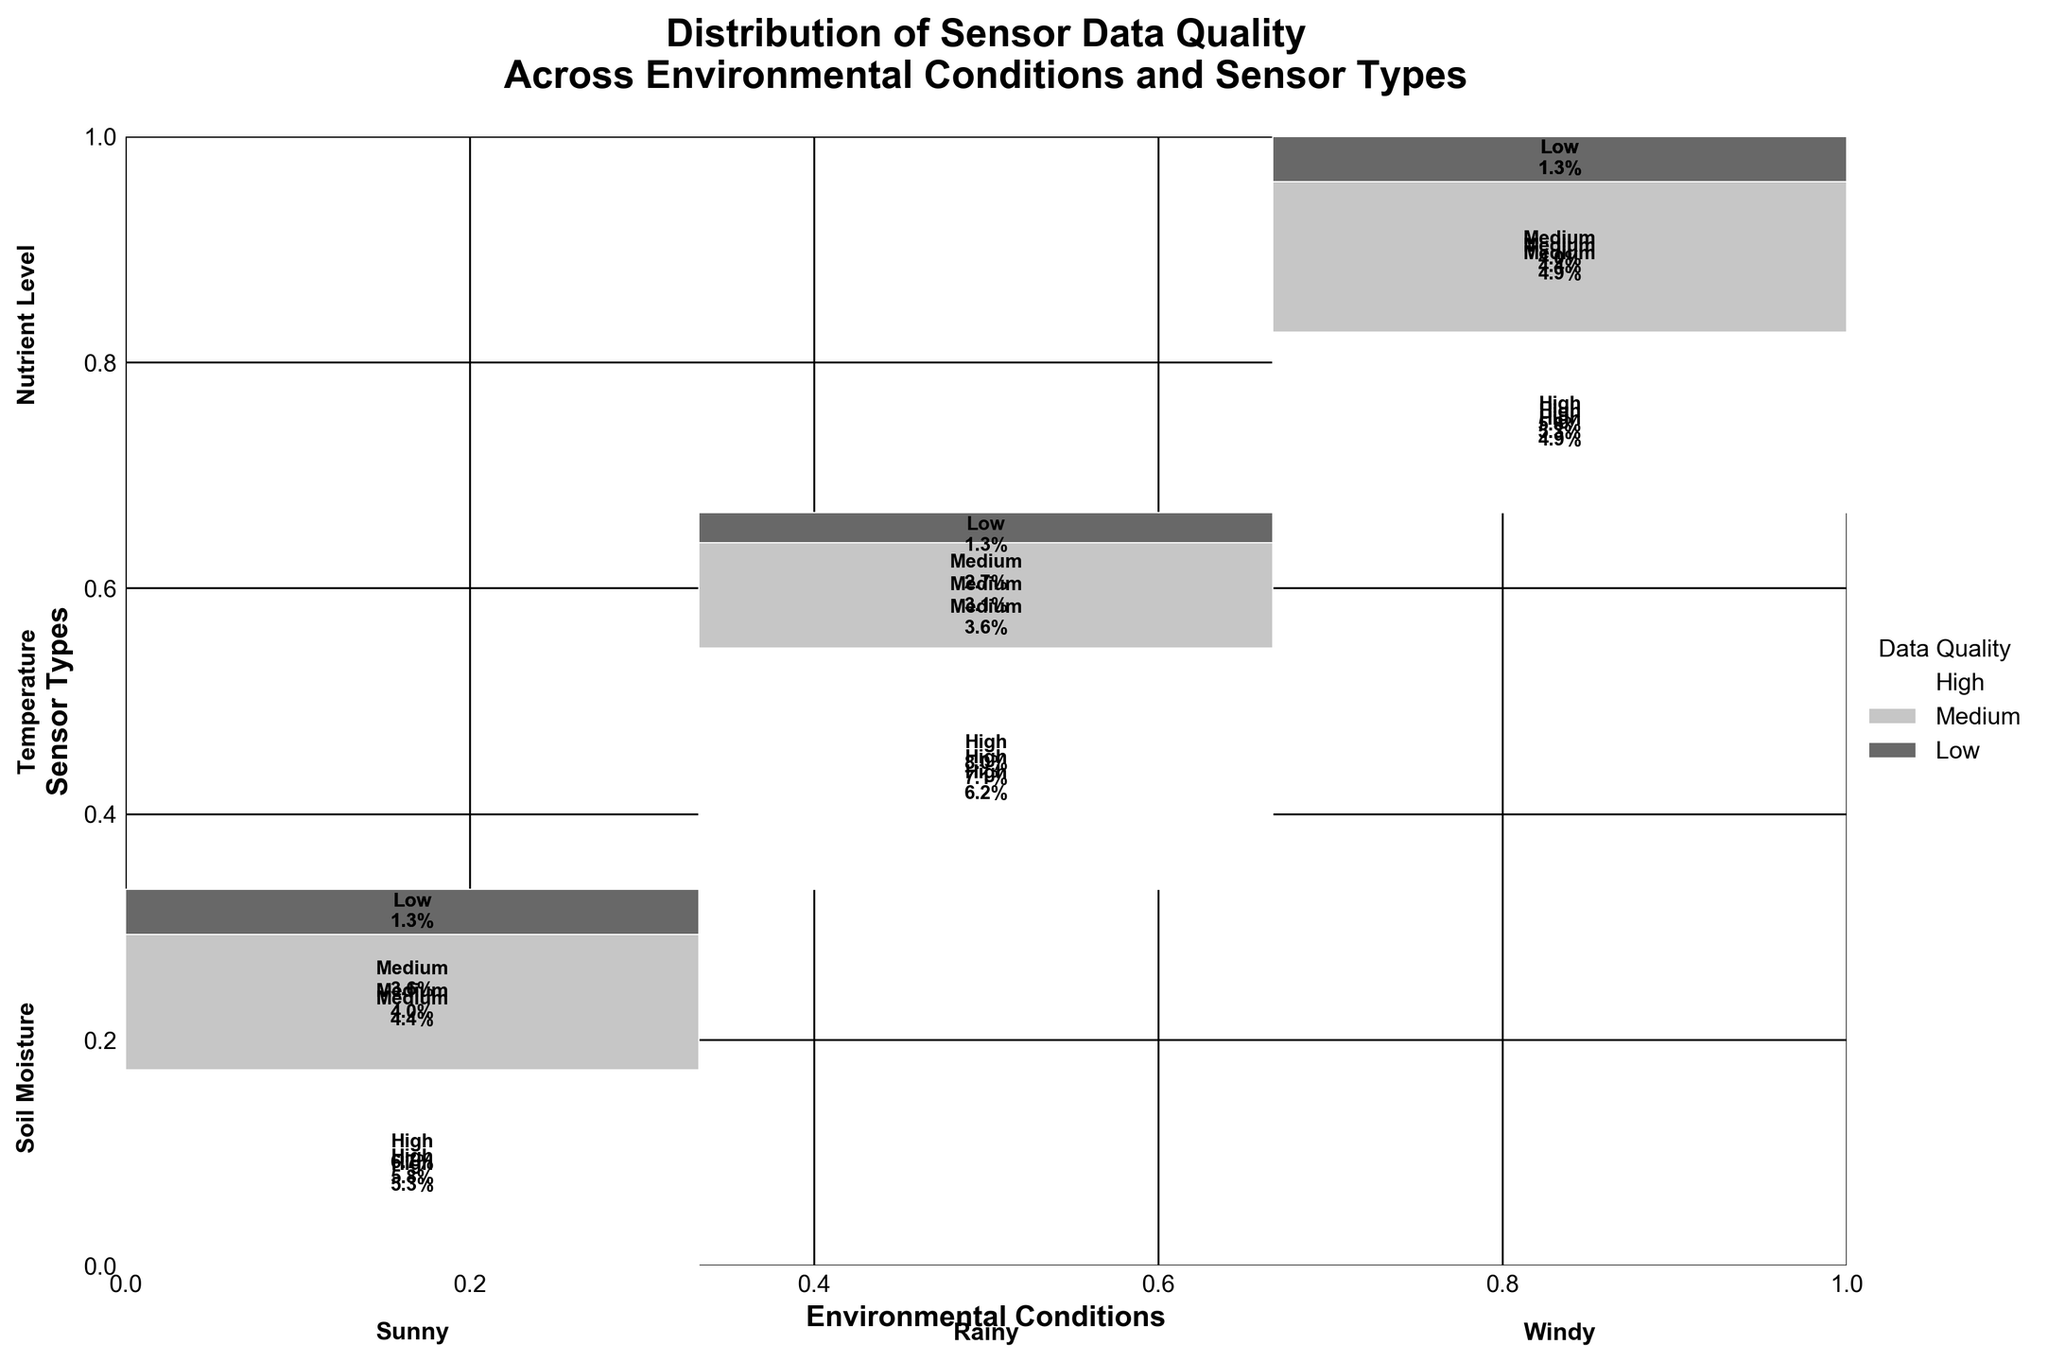What is the title of the mosaic plot? The title of the mosaic plot is written at the top of the figure.
Answer: Distribution of Sensor Data Quality Across Environmental Conditions and Sensor Types Which environmental condition has the highest proportion of high data quality? The height of the rectangles associated with high data quality segments across different environmental conditions helps to determine this. Sunny has the highest proportion for high data quality.
Answer: Sunny What is the proportion of medium data quality for Soil Moisture sensors under Rainy conditions? Locate the segments for Soil Moisture and Rainy conditions and focus on the medium data quality segment. It's approximately 22.6%.
Answer: 22.6% How does the data quality distribution for Temperature sensors compare between Sunny and Windy conditions? By comparing the sizes of the high, medium, and low data quality segments for Temperature sensors under Sunny and Windy conditions, one notices that the high data quality proportion is slightly greater under Sunny conditions than Windy, while the low data quality proportion is similar for both.
Answer: Higher high quality under Sunny, similar low quality Which sensor type has the most even distribution of data quality across all environmental conditions? By visually inspecting the proportional distribution of high, medium, and low data quality for each sensor type under different conditions, Nutrient Level sensors appear to have the most balanced distribution.
Answer: Nutrient Level What is the total proportion of low data quality across all sensor types and conditions? Add up the proportions of low data quality segments across all sensor types and environmental conditions. The low data quality segments across all categories are around 14.9%.
Answer: 14.9% Under Windy conditions, which data quality category for Temperature sensors takes up more area: high or medium? Compare the area of the high data quality segment to the medium data quality segment for Temperature sensors under Windy conditions. The high data quality segment is larger.
Answer: High Is there a noticeable trend in data quality between Sunny and Rainy conditions for any specific sensor type? Evaluate each sensor type's data quality distribution under Sunny and Rainy conditions. Soil Moisture sensors tend to have a larger high-quality segment under Sunny conditions compared to Rainy conditions.
Answer: Larger high quality under Sunny for Soil Moisture 